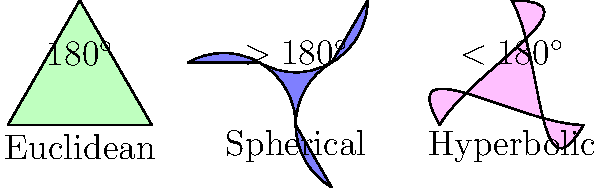As a forum moderator who values diplomacy and clear communication, you're tasked with explaining the differences in triangle angle sums across various geometries. Based on the diagram, which type of geometry allows for triangles with an angle sum greater than 180°, and why might this be significant in discussions about non-Euclidean geometry? To answer this question, let's analyze the diagram step-by-step:

1. The diagram shows three types of triangles: Euclidean, Spherical, and Hyperbolic.

2. Euclidean triangle (green):
   - In Euclidean geometry, the sum of angles in a triangle is always 180°.
   - This is the geometry we're most familiar with on a flat plane.

3. Spherical triangle (blue):
   - The label indicates that the angle sum is $>180^\circ$.
   - This occurs on the surface of a sphere, where straight lines are actually great circles.

4. Hyperbolic triangle (pink):
   - The label shows that the angle sum is $<180^\circ$.
   - This geometry occurs on saddle-shaped surfaces.

5. Significance in non-Euclidean geometry discussions:
   - Spherical geometry allows for triangles with angle sums greater than 180°.
   - This challenges our intuitive understanding of triangles.
   - It demonstrates that geometric properties can vary depending on the surface or space.
   - Understanding spherical geometry is crucial for navigation on a global scale and in astronomy.

6. In diplomatic discussions:
   - This concept illustrates that different perspectives (geometries) can lead to different truths.
   - It encourages open-mindedness and consideration of alternative viewpoints.
   - It demonstrates the importance of clearly defining the context or "rules" in any discussion.

Therefore, spherical geometry allows for triangles with an angle sum greater than 180°. This is significant because it broadens our understanding of geometric possibilities and encourages flexible thinking in mathematical and real-world contexts.
Answer: Spherical geometry; it demonstrates alternative mathematical truths, encouraging open-mindedness in discussions. 